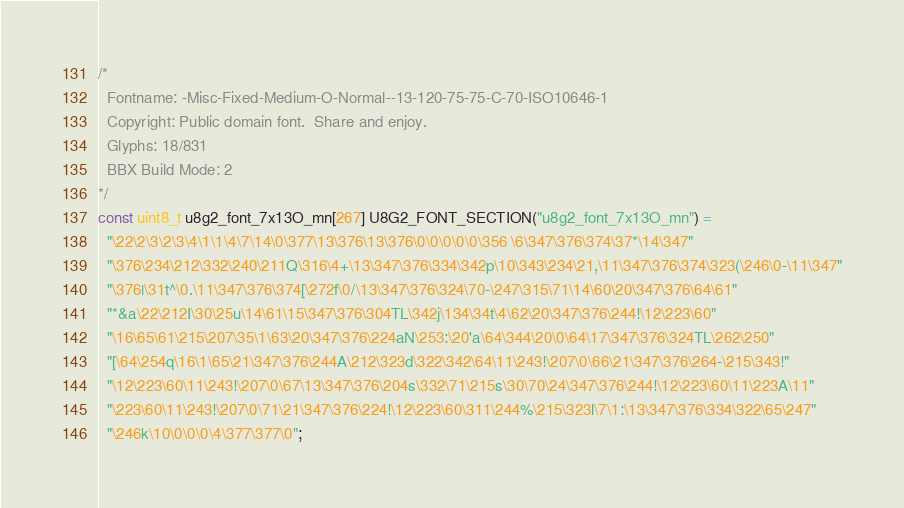<code> <loc_0><loc_0><loc_500><loc_500><_C_>/*
  Fontname: -Misc-Fixed-Medium-O-Normal--13-120-75-75-C-70-ISO10646-1
  Copyright: Public domain font.  Share and enjoy.
  Glyphs: 18/831
  BBX Build Mode: 2
*/
const uint8_t u8g2_font_7x13O_mn[267] U8G2_FONT_SECTION("u8g2_font_7x13O_mn") = 
  "\22\2\3\2\3\4\1\1\4\7\14\0\377\13\376\13\376\0\0\0\0\0\356 \6\347\376\374\37*\14\347"
  "\376\234\212\332\240\211Q\316\4+\13\347\376\334\342p\10\343\234\21,\11\347\376\374\323(\246\0-\11\347"
  "\376|\31t^\0.\11\347\376\374[\272f\0/\13\347\376\324\70-\247\315\71\14\60\20\347\376\64\61"
  "*&a\22\212I\30\25u\14\61\15\347\376\304TL\342j\134\34t\4\62\20\347\376\244!\12\223\60"
  "\16\65\61\215\207\35\1\63\20\347\376\224aN\253:\20'a\64\344\20\0\64\17\347\376\324TL\262\250"
  "[\64\254q\16\1\65\21\347\376\244A\212\323d\322\342\64\11\243!\207\0\66\21\347\376\264-\215\343!"
  "\12\223\60\11\243!\207\0\67\13\347\376\204s\332\71\215s\30\70\24\347\376\244!\12\223\60\11\223A\11"
  "\223\60\11\243!\207\0\71\21\347\376\224!\12\223\60\311\244%\215\323l\7\1:\13\347\376\334\322\65\247"
  "\246k\10\0\0\0\4\377\377\0";
</code> 